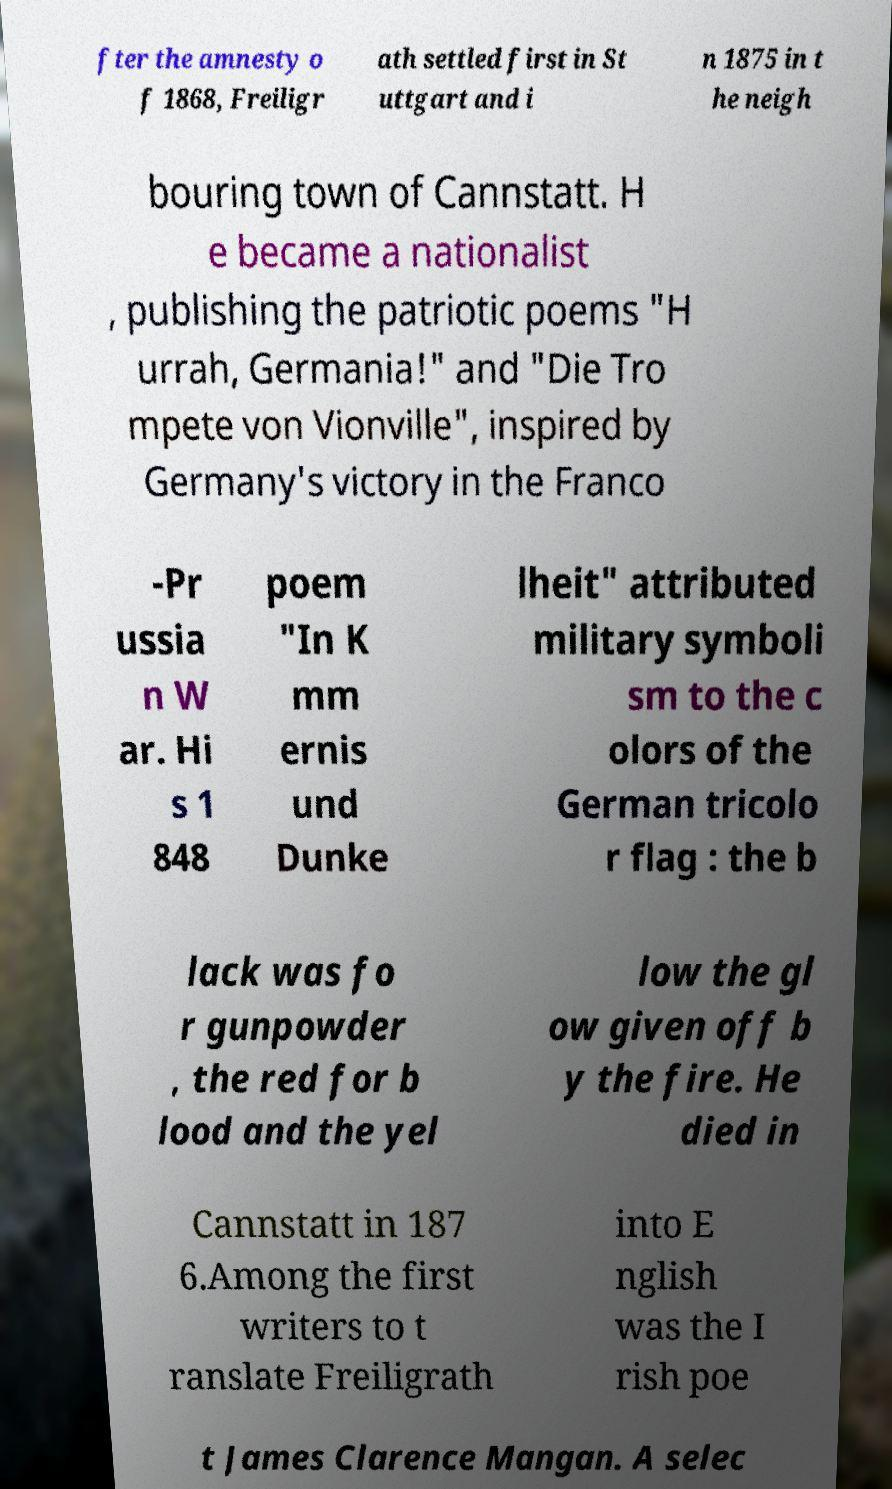What messages or text are displayed in this image? I need them in a readable, typed format. fter the amnesty o f 1868, Freiligr ath settled first in St uttgart and i n 1875 in t he neigh bouring town of Cannstatt. H e became a nationalist , publishing the patriotic poems "H urrah, Germania!" and "Die Tro mpete von Vionville", inspired by Germany's victory in the Franco -Pr ussia n W ar. Hi s 1 848 poem "In K mm ernis und Dunke lheit" attributed military symboli sm to the c olors of the German tricolo r flag : the b lack was fo r gunpowder , the red for b lood and the yel low the gl ow given off b y the fire. He died in Cannstatt in 187 6.Among the first writers to t ranslate Freiligrath into E nglish was the I rish poe t James Clarence Mangan. A selec 